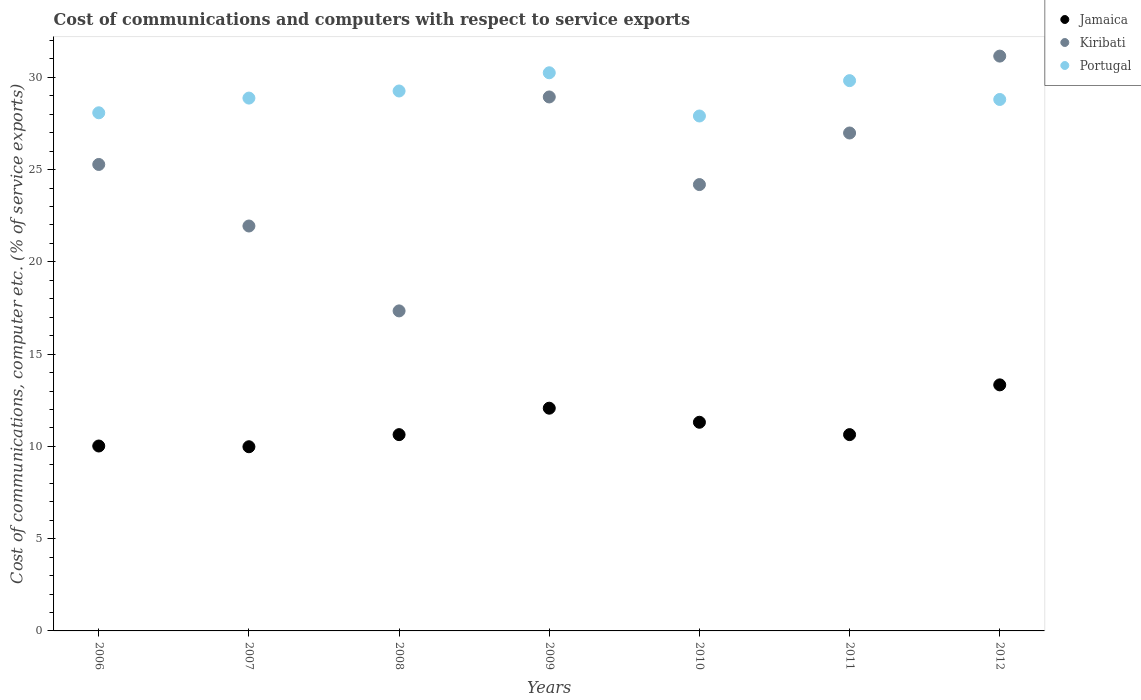Is the number of dotlines equal to the number of legend labels?
Your answer should be compact. Yes. What is the cost of communications and computers in Jamaica in 2006?
Your answer should be compact. 10.02. Across all years, what is the maximum cost of communications and computers in Portugal?
Give a very brief answer. 30.25. Across all years, what is the minimum cost of communications and computers in Jamaica?
Keep it short and to the point. 9.98. In which year was the cost of communications and computers in Portugal maximum?
Keep it short and to the point. 2009. In which year was the cost of communications and computers in Jamaica minimum?
Give a very brief answer. 2007. What is the total cost of communications and computers in Kiribati in the graph?
Your answer should be very brief. 175.83. What is the difference between the cost of communications and computers in Portugal in 2009 and that in 2010?
Offer a very short reply. 2.34. What is the difference between the cost of communications and computers in Kiribati in 2006 and the cost of communications and computers in Portugal in 2009?
Your answer should be very brief. -4.97. What is the average cost of communications and computers in Jamaica per year?
Provide a succinct answer. 11.14. In the year 2012, what is the difference between the cost of communications and computers in Portugal and cost of communications and computers in Kiribati?
Keep it short and to the point. -2.35. What is the ratio of the cost of communications and computers in Jamaica in 2006 to that in 2010?
Provide a short and direct response. 0.89. What is the difference between the highest and the second highest cost of communications and computers in Kiribati?
Provide a succinct answer. 2.21. What is the difference between the highest and the lowest cost of communications and computers in Jamaica?
Provide a short and direct response. 3.35. In how many years, is the cost of communications and computers in Portugal greater than the average cost of communications and computers in Portugal taken over all years?
Provide a short and direct response. 3. Is the sum of the cost of communications and computers in Kiribati in 2009 and 2011 greater than the maximum cost of communications and computers in Jamaica across all years?
Make the answer very short. Yes. Does the cost of communications and computers in Kiribati monotonically increase over the years?
Your answer should be very brief. No. How many years are there in the graph?
Give a very brief answer. 7. Are the values on the major ticks of Y-axis written in scientific E-notation?
Provide a short and direct response. No. Does the graph contain grids?
Give a very brief answer. No. How are the legend labels stacked?
Your answer should be compact. Vertical. What is the title of the graph?
Provide a succinct answer. Cost of communications and computers with respect to service exports. What is the label or title of the Y-axis?
Make the answer very short. Cost of communications, computer etc. (% of service exports). What is the Cost of communications, computer etc. (% of service exports) in Jamaica in 2006?
Keep it short and to the point. 10.02. What is the Cost of communications, computer etc. (% of service exports) in Kiribati in 2006?
Provide a short and direct response. 25.28. What is the Cost of communications, computer etc. (% of service exports) in Portugal in 2006?
Provide a short and direct response. 28.08. What is the Cost of communications, computer etc. (% of service exports) of Jamaica in 2007?
Provide a succinct answer. 9.98. What is the Cost of communications, computer etc. (% of service exports) in Kiribati in 2007?
Your answer should be very brief. 21.94. What is the Cost of communications, computer etc. (% of service exports) of Portugal in 2007?
Your response must be concise. 28.88. What is the Cost of communications, computer etc. (% of service exports) in Jamaica in 2008?
Keep it short and to the point. 10.64. What is the Cost of communications, computer etc. (% of service exports) of Kiribati in 2008?
Keep it short and to the point. 17.34. What is the Cost of communications, computer etc. (% of service exports) in Portugal in 2008?
Keep it short and to the point. 29.26. What is the Cost of communications, computer etc. (% of service exports) of Jamaica in 2009?
Provide a succinct answer. 12.07. What is the Cost of communications, computer etc. (% of service exports) of Kiribati in 2009?
Your answer should be compact. 28.94. What is the Cost of communications, computer etc. (% of service exports) of Portugal in 2009?
Give a very brief answer. 30.25. What is the Cost of communications, computer etc. (% of service exports) in Jamaica in 2010?
Make the answer very short. 11.31. What is the Cost of communications, computer etc. (% of service exports) in Kiribati in 2010?
Offer a very short reply. 24.19. What is the Cost of communications, computer etc. (% of service exports) of Portugal in 2010?
Provide a succinct answer. 27.91. What is the Cost of communications, computer etc. (% of service exports) of Jamaica in 2011?
Ensure brevity in your answer.  10.64. What is the Cost of communications, computer etc. (% of service exports) of Kiribati in 2011?
Your answer should be very brief. 26.98. What is the Cost of communications, computer etc. (% of service exports) in Portugal in 2011?
Give a very brief answer. 29.82. What is the Cost of communications, computer etc. (% of service exports) in Jamaica in 2012?
Your response must be concise. 13.33. What is the Cost of communications, computer etc. (% of service exports) in Kiribati in 2012?
Offer a terse response. 31.15. What is the Cost of communications, computer etc. (% of service exports) in Portugal in 2012?
Provide a short and direct response. 28.8. Across all years, what is the maximum Cost of communications, computer etc. (% of service exports) of Jamaica?
Your answer should be compact. 13.33. Across all years, what is the maximum Cost of communications, computer etc. (% of service exports) in Kiribati?
Offer a terse response. 31.15. Across all years, what is the maximum Cost of communications, computer etc. (% of service exports) of Portugal?
Ensure brevity in your answer.  30.25. Across all years, what is the minimum Cost of communications, computer etc. (% of service exports) in Jamaica?
Give a very brief answer. 9.98. Across all years, what is the minimum Cost of communications, computer etc. (% of service exports) of Kiribati?
Your answer should be compact. 17.34. Across all years, what is the minimum Cost of communications, computer etc. (% of service exports) in Portugal?
Ensure brevity in your answer.  27.91. What is the total Cost of communications, computer etc. (% of service exports) in Jamaica in the graph?
Make the answer very short. 77.99. What is the total Cost of communications, computer etc. (% of service exports) of Kiribati in the graph?
Give a very brief answer. 175.83. What is the total Cost of communications, computer etc. (% of service exports) in Portugal in the graph?
Offer a terse response. 202.99. What is the difference between the Cost of communications, computer etc. (% of service exports) of Jamaica in 2006 and that in 2007?
Keep it short and to the point. 0.04. What is the difference between the Cost of communications, computer etc. (% of service exports) of Kiribati in 2006 and that in 2007?
Your answer should be compact. 3.33. What is the difference between the Cost of communications, computer etc. (% of service exports) in Portugal in 2006 and that in 2007?
Ensure brevity in your answer.  -0.8. What is the difference between the Cost of communications, computer etc. (% of service exports) of Jamaica in 2006 and that in 2008?
Provide a short and direct response. -0.62. What is the difference between the Cost of communications, computer etc. (% of service exports) of Kiribati in 2006 and that in 2008?
Make the answer very short. 7.94. What is the difference between the Cost of communications, computer etc. (% of service exports) in Portugal in 2006 and that in 2008?
Your response must be concise. -1.18. What is the difference between the Cost of communications, computer etc. (% of service exports) of Jamaica in 2006 and that in 2009?
Your response must be concise. -2.05. What is the difference between the Cost of communications, computer etc. (% of service exports) of Kiribati in 2006 and that in 2009?
Make the answer very short. -3.66. What is the difference between the Cost of communications, computer etc. (% of service exports) of Portugal in 2006 and that in 2009?
Offer a terse response. -2.17. What is the difference between the Cost of communications, computer etc. (% of service exports) of Jamaica in 2006 and that in 2010?
Offer a terse response. -1.29. What is the difference between the Cost of communications, computer etc. (% of service exports) of Kiribati in 2006 and that in 2010?
Offer a very short reply. 1.09. What is the difference between the Cost of communications, computer etc. (% of service exports) in Portugal in 2006 and that in 2010?
Your response must be concise. 0.17. What is the difference between the Cost of communications, computer etc. (% of service exports) in Jamaica in 2006 and that in 2011?
Offer a very short reply. -0.62. What is the difference between the Cost of communications, computer etc. (% of service exports) of Kiribati in 2006 and that in 2011?
Offer a terse response. -1.71. What is the difference between the Cost of communications, computer etc. (% of service exports) of Portugal in 2006 and that in 2011?
Your answer should be very brief. -1.74. What is the difference between the Cost of communications, computer etc. (% of service exports) in Jamaica in 2006 and that in 2012?
Your answer should be very brief. -3.31. What is the difference between the Cost of communications, computer etc. (% of service exports) of Kiribati in 2006 and that in 2012?
Your answer should be compact. -5.87. What is the difference between the Cost of communications, computer etc. (% of service exports) of Portugal in 2006 and that in 2012?
Your answer should be compact. -0.72. What is the difference between the Cost of communications, computer etc. (% of service exports) of Jamaica in 2007 and that in 2008?
Provide a short and direct response. -0.66. What is the difference between the Cost of communications, computer etc. (% of service exports) of Kiribati in 2007 and that in 2008?
Ensure brevity in your answer.  4.6. What is the difference between the Cost of communications, computer etc. (% of service exports) of Portugal in 2007 and that in 2008?
Provide a succinct answer. -0.38. What is the difference between the Cost of communications, computer etc. (% of service exports) in Jamaica in 2007 and that in 2009?
Provide a succinct answer. -2.09. What is the difference between the Cost of communications, computer etc. (% of service exports) in Kiribati in 2007 and that in 2009?
Keep it short and to the point. -6.99. What is the difference between the Cost of communications, computer etc. (% of service exports) in Portugal in 2007 and that in 2009?
Offer a very short reply. -1.37. What is the difference between the Cost of communications, computer etc. (% of service exports) in Jamaica in 2007 and that in 2010?
Make the answer very short. -1.33. What is the difference between the Cost of communications, computer etc. (% of service exports) in Kiribati in 2007 and that in 2010?
Provide a short and direct response. -2.25. What is the difference between the Cost of communications, computer etc. (% of service exports) in Portugal in 2007 and that in 2010?
Make the answer very short. 0.97. What is the difference between the Cost of communications, computer etc. (% of service exports) of Jamaica in 2007 and that in 2011?
Give a very brief answer. -0.66. What is the difference between the Cost of communications, computer etc. (% of service exports) in Kiribati in 2007 and that in 2011?
Provide a short and direct response. -5.04. What is the difference between the Cost of communications, computer etc. (% of service exports) in Portugal in 2007 and that in 2011?
Your answer should be compact. -0.95. What is the difference between the Cost of communications, computer etc. (% of service exports) in Jamaica in 2007 and that in 2012?
Provide a short and direct response. -3.35. What is the difference between the Cost of communications, computer etc. (% of service exports) in Kiribati in 2007 and that in 2012?
Your answer should be very brief. -9.21. What is the difference between the Cost of communications, computer etc. (% of service exports) of Portugal in 2007 and that in 2012?
Make the answer very short. 0.07. What is the difference between the Cost of communications, computer etc. (% of service exports) in Jamaica in 2008 and that in 2009?
Keep it short and to the point. -1.43. What is the difference between the Cost of communications, computer etc. (% of service exports) in Kiribati in 2008 and that in 2009?
Your response must be concise. -11.59. What is the difference between the Cost of communications, computer etc. (% of service exports) in Portugal in 2008 and that in 2009?
Provide a short and direct response. -0.99. What is the difference between the Cost of communications, computer etc. (% of service exports) of Jamaica in 2008 and that in 2010?
Your response must be concise. -0.67. What is the difference between the Cost of communications, computer etc. (% of service exports) of Kiribati in 2008 and that in 2010?
Keep it short and to the point. -6.85. What is the difference between the Cost of communications, computer etc. (% of service exports) in Portugal in 2008 and that in 2010?
Provide a succinct answer. 1.35. What is the difference between the Cost of communications, computer etc. (% of service exports) of Jamaica in 2008 and that in 2011?
Your answer should be compact. -0. What is the difference between the Cost of communications, computer etc. (% of service exports) of Kiribati in 2008 and that in 2011?
Ensure brevity in your answer.  -9.64. What is the difference between the Cost of communications, computer etc. (% of service exports) in Portugal in 2008 and that in 2011?
Provide a short and direct response. -0.56. What is the difference between the Cost of communications, computer etc. (% of service exports) of Jamaica in 2008 and that in 2012?
Make the answer very short. -2.7. What is the difference between the Cost of communications, computer etc. (% of service exports) of Kiribati in 2008 and that in 2012?
Your response must be concise. -13.81. What is the difference between the Cost of communications, computer etc. (% of service exports) of Portugal in 2008 and that in 2012?
Your answer should be very brief. 0.46. What is the difference between the Cost of communications, computer etc. (% of service exports) in Jamaica in 2009 and that in 2010?
Keep it short and to the point. 0.76. What is the difference between the Cost of communications, computer etc. (% of service exports) of Kiribati in 2009 and that in 2010?
Provide a short and direct response. 4.75. What is the difference between the Cost of communications, computer etc. (% of service exports) in Portugal in 2009 and that in 2010?
Make the answer very short. 2.34. What is the difference between the Cost of communications, computer etc. (% of service exports) in Jamaica in 2009 and that in 2011?
Offer a terse response. 1.43. What is the difference between the Cost of communications, computer etc. (% of service exports) in Kiribati in 2009 and that in 2011?
Give a very brief answer. 1.95. What is the difference between the Cost of communications, computer etc. (% of service exports) in Portugal in 2009 and that in 2011?
Offer a very short reply. 0.43. What is the difference between the Cost of communications, computer etc. (% of service exports) of Jamaica in 2009 and that in 2012?
Keep it short and to the point. -1.26. What is the difference between the Cost of communications, computer etc. (% of service exports) of Kiribati in 2009 and that in 2012?
Keep it short and to the point. -2.21. What is the difference between the Cost of communications, computer etc. (% of service exports) in Portugal in 2009 and that in 2012?
Make the answer very short. 1.45. What is the difference between the Cost of communications, computer etc. (% of service exports) of Jamaica in 2010 and that in 2011?
Ensure brevity in your answer.  0.67. What is the difference between the Cost of communications, computer etc. (% of service exports) of Kiribati in 2010 and that in 2011?
Your answer should be very brief. -2.8. What is the difference between the Cost of communications, computer etc. (% of service exports) of Portugal in 2010 and that in 2011?
Give a very brief answer. -1.92. What is the difference between the Cost of communications, computer etc. (% of service exports) of Jamaica in 2010 and that in 2012?
Ensure brevity in your answer.  -2.03. What is the difference between the Cost of communications, computer etc. (% of service exports) of Kiribati in 2010 and that in 2012?
Your answer should be compact. -6.96. What is the difference between the Cost of communications, computer etc. (% of service exports) in Portugal in 2010 and that in 2012?
Give a very brief answer. -0.9. What is the difference between the Cost of communications, computer etc. (% of service exports) of Jamaica in 2011 and that in 2012?
Provide a short and direct response. -2.7. What is the difference between the Cost of communications, computer etc. (% of service exports) in Kiribati in 2011 and that in 2012?
Offer a very short reply. -4.17. What is the difference between the Cost of communications, computer etc. (% of service exports) in Portugal in 2011 and that in 2012?
Offer a terse response. 1.02. What is the difference between the Cost of communications, computer etc. (% of service exports) of Jamaica in 2006 and the Cost of communications, computer etc. (% of service exports) of Kiribati in 2007?
Keep it short and to the point. -11.92. What is the difference between the Cost of communications, computer etc. (% of service exports) in Jamaica in 2006 and the Cost of communications, computer etc. (% of service exports) in Portugal in 2007?
Make the answer very short. -18.85. What is the difference between the Cost of communications, computer etc. (% of service exports) in Kiribati in 2006 and the Cost of communications, computer etc. (% of service exports) in Portugal in 2007?
Ensure brevity in your answer.  -3.6. What is the difference between the Cost of communications, computer etc. (% of service exports) in Jamaica in 2006 and the Cost of communications, computer etc. (% of service exports) in Kiribati in 2008?
Your response must be concise. -7.32. What is the difference between the Cost of communications, computer etc. (% of service exports) in Jamaica in 2006 and the Cost of communications, computer etc. (% of service exports) in Portugal in 2008?
Ensure brevity in your answer.  -19.24. What is the difference between the Cost of communications, computer etc. (% of service exports) of Kiribati in 2006 and the Cost of communications, computer etc. (% of service exports) of Portugal in 2008?
Offer a very short reply. -3.98. What is the difference between the Cost of communications, computer etc. (% of service exports) in Jamaica in 2006 and the Cost of communications, computer etc. (% of service exports) in Kiribati in 2009?
Provide a short and direct response. -18.92. What is the difference between the Cost of communications, computer etc. (% of service exports) in Jamaica in 2006 and the Cost of communications, computer etc. (% of service exports) in Portugal in 2009?
Give a very brief answer. -20.23. What is the difference between the Cost of communications, computer etc. (% of service exports) of Kiribati in 2006 and the Cost of communications, computer etc. (% of service exports) of Portugal in 2009?
Offer a terse response. -4.97. What is the difference between the Cost of communications, computer etc. (% of service exports) in Jamaica in 2006 and the Cost of communications, computer etc. (% of service exports) in Kiribati in 2010?
Offer a very short reply. -14.17. What is the difference between the Cost of communications, computer etc. (% of service exports) of Jamaica in 2006 and the Cost of communications, computer etc. (% of service exports) of Portugal in 2010?
Provide a short and direct response. -17.88. What is the difference between the Cost of communications, computer etc. (% of service exports) in Kiribati in 2006 and the Cost of communications, computer etc. (% of service exports) in Portugal in 2010?
Your response must be concise. -2.63. What is the difference between the Cost of communications, computer etc. (% of service exports) of Jamaica in 2006 and the Cost of communications, computer etc. (% of service exports) of Kiribati in 2011?
Make the answer very short. -16.96. What is the difference between the Cost of communications, computer etc. (% of service exports) of Jamaica in 2006 and the Cost of communications, computer etc. (% of service exports) of Portugal in 2011?
Keep it short and to the point. -19.8. What is the difference between the Cost of communications, computer etc. (% of service exports) of Kiribati in 2006 and the Cost of communications, computer etc. (% of service exports) of Portugal in 2011?
Ensure brevity in your answer.  -4.54. What is the difference between the Cost of communications, computer etc. (% of service exports) in Jamaica in 2006 and the Cost of communications, computer etc. (% of service exports) in Kiribati in 2012?
Provide a succinct answer. -21.13. What is the difference between the Cost of communications, computer etc. (% of service exports) of Jamaica in 2006 and the Cost of communications, computer etc. (% of service exports) of Portugal in 2012?
Your response must be concise. -18.78. What is the difference between the Cost of communications, computer etc. (% of service exports) of Kiribati in 2006 and the Cost of communications, computer etc. (% of service exports) of Portugal in 2012?
Keep it short and to the point. -3.52. What is the difference between the Cost of communications, computer etc. (% of service exports) of Jamaica in 2007 and the Cost of communications, computer etc. (% of service exports) of Kiribati in 2008?
Offer a very short reply. -7.36. What is the difference between the Cost of communications, computer etc. (% of service exports) of Jamaica in 2007 and the Cost of communications, computer etc. (% of service exports) of Portugal in 2008?
Offer a very short reply. -19.28. What is the difference between the Cost of communications, computer etc. (% of service exports) of Kiribati in 2007 and the Cost of communications, computer etc. (% of service exports) of Portugal in 2008?
Offer a terse response. -7.32. What is the difference between the Cost of communications, computer etc. (% of service exports) of Jamaica in 2007 and the Cost of communications, computer etc. (% of service exports) of Kiribati in 2009?
Offer a terse response. -18.96. What is the difference between the Cost of communications, computer etc. (% of service exports) in Jamaica in 2007 and the Cost of communications, computer etc. (% of service exports) in Portugal in 2009?
Your response must be concise. -20.27. What is the difference between the Cost of communications, computer etc. (% of service exports) of Kiribati in 2007 and the Cost of communications, computer etc. (% of service exports) of Portugal in 2009?
Ensure brevity in your answer.  -8.3. What is the difference between the Cost of communications, computer etc. (% of service exports) of Jamaica in 2007 and the Cost of communications, computer etc. (% of service exports) of Kiribati in 2010?
Ensure brevity in your answer.  -14.21. What is the difference between the Cost of communications, computer etc. (% of service exports) of Jamaica in 2007 and the Cost of communications, computer etc. (% of service exports) of Portugal in 2010?
Your response must be concise. -17.92. What is the difference between the Cost of communications, computer etc. (% of service exports) in Kiribati in 2007 and the Cost of communications, computer etc. (% of service exports) in Portugal in 2010?
Make the answer very short. -5.96. What is the difference between the Cost of communications, computer etc. (% of service exports) in Jamaica in 2007 and the Cost of communications, computer etc. (% of service exports) in Kiribati in 2011?
Provide a short and direct response. -17. What is the difference between the Cost of communications, computer etc. (% of service exports) of Jamaica in 2007 and the Cost of communications, computer etc. (% of service exports) of Portugal in 2011?
Make the answer very short. -19.84. What is the difference between the Cost of communications, computer etc. (% of service exports) of Kiribati in 2007 and the Cost of communications, computer etc. (% of service exports) of Portugal in 2011?
Make the answer very short. -7.88. What is the difference between the Cost of communications, computer etc. (% of service exports) of Jamaica in 2007 and the Cost of communications, computer etc. (% of service exports) of Kiribati in 2012?
Provide a short and direct response. -21.17. What is the difference between the Cost of communications, computer etc. (% of service exports) of Jamaica in 2007 and the Cost of communications, computer etc. (% of service exports) of Portugal in 2012?
Your response must be concise. -18.82. What is the difference between the Cost of communications, computer etc. (% of service exports) in Kiribati in 2007 and the Cost of communications, computer etc. (% of service exports) in Portugal in 2012?
Give a very brief answer. -6.86. What is the difference between the Cost of communications, computer etc. (% of service exports) in Jamaica in 2008 and the Cost of communications, computer etc. (% of service exports) in Kiribati in 2009?
Your response must be concise. -18.3. What is the difference between the Cost of communications, computer etc. (% of service exports) of Jamaica in 2008 and the Cost of communications, computer etc. (% of service exports) of Portugal in 2009?
Make the answer very short. -19.61. What is the difference between the Cost of communications, computer etc. (% of service exports) in Kiribati in 2008 and the Cost of communications, computer etc. (% of service exports) in Portugal in 2009?
Keep it short and to the point. -12.9. What is the difference between the Cost of communications, computer etc. (% of service exports) of Jamaica in 2008 and the Cost of communications, computer etc. (% of service exports) of Kiribati in 2010?
Your response must be concise. -13.55. What is the difference between the Cost of communications, computer etc. (% of service exports) of Jamaica in 2008 and the Cost of communications, computer etc. (% of service exports) of Portugal in 2010?
Ensure brevity in your answer.  -17.27. What is the difference between the Cost of communications, computer etc. (% of service exports) in Kiribati in 2008 and the Cost of communications, computer etc. (% of service exports) in Portugal in 2010?
Provide a short and direct response. -10.56. What is the difference between the Cost of communications, computer etc. (% of service exports) of Jamaica in 2008 and the Cost of communications, computer etc. (% of service exports) of Kiribati in 2011?
Your answer should be compact. -16.35. What is the difference between the Cost of communications, computer etc. (% of service exports) of Jamaica in 2008 and the Cost of communications, computer etc. (% of service exports) of Portugal in 2011?
Provide a succinct answer. -19.18. What is the difference between the Cost of communications, computer etc. (% of service exports) in Kiribati in 2008 and the Cost of communications, computer etc. (% of service exports) in Portugal in 2011?
Give a very brief answer. -12.48. What is the difference between the Cost of communications, computer etc. (% of service exports) of Jamaica in 2008 and the Cost of communications, computer etc. (% of service exports) of Kiribati in 2012?
Your response must be concise. -20.51. What is the difference between the Cost of communications, computer etc. (% of service exports) in Jamaica in 2008 and the Cost of communications, computer etc. (% of service exports) in Portugal in 2012?
Give a very brief answer. -18.16. What is the difference between the Cost of communications, computer etc. (% of service exports) of Kiribati in 2008 and the Cost of communications, computer etc. (% of service exports) of Portugal in 2012?
Make the answer very short. -11.46. What is the difference between the Cost of communications, computer etc. (% of service exports) in Jamaica in 2009 and the Cost of communications, computer etc. (% of service exports) in Kiribati in 2010?
Keep it short and to the point. -12.12. What is the difference between the Cost of communications, computer etc. (% of service exports) in Jamaica in 2009 and the Cost of communications, computer etc. (% of service exports) in Portugal in 2010?
Make the answer very short. -15.84. What is the difference between the Cost of communications, computer etc. (% of service exports) of Kiribati in 2009 and the Cost of communications, computer etc. (% of service exports) of Portugal in 2010?
Provide a succinct answer. 1.03. What is the difference between the Cost of communications, computer etc. (% of service exports) of Jamaica in 2009 and the Cost of communications, computer etc. (% of service exports) of Kiribati in 2011?
Provide a short and direct response. -14.91. What is the difference between the Cost of communications, computer etc. (% of service exports) of Jamaica in 2009 and the Cost of communications, computer etc. (% of service exports) of Portugal in 2011?
Keep it short and to the point. -17.75. What is the difference between the Cost of communications, computer etc. (% of service exports) in Kiribati in 2009 and the Cost of communications, computer etc. (% of service exports) in Portugal in 2011?
Your answer should be compact. -0.88. What is the difference between the Cost of communications, computer etc. (% of service exports) of Jamaica in 2009 and the Cost of communications, computer etc. (% of service exports) of Kiribati in 2012?
Offer a very short reply. -19.08. What is the difference between the Cost of communications, computer etc. (% of service exports) of Jamaica in 2009 and the Cost of communications, computer etc. (% of service exports) of Portugal in 2012?
Provide a short and direct response. -16.73. What is the difference between the Cost of communications, computer etc. (% of service exports) in Kiribati in 2009 and the Cost of communications, computer etc. (% of service exports) in Portugal in 2012?
Give a very brief answer. 0.14. What is the difference between the Cost of communications, computer etc. (% of service exports) of Jamaica in 2010 and the Cost of communications, computer etc. (% of service exports) of Kiribati in 2011?
Your answer should be very brief. -15.68. What is the difference between the Cost of communications, computer etc. (% of service exports) in Jamaica in 2010 and the Cost of communications, computer etc. (% of service exports) in Portugal in 2011?
Offer a terse response. -18.51. What is the difference between the Cost of communications, computer etc. (% of service exports) in Kiribati in 2010 and the Cost of communications, computer etc. (% of service exports) in Portugal in 2011?
Your answer should be compact. -5.63. What is the difference between the Cost of communications, computer etc. (% of service exports) of Jamaica in 2010 and the Cost of communications, computer etc. (% of service exports) of Kiribati in 2012?
Give a very brief answer. -19.84. What is the difference between the Cost of communications, computer etc. (% of service exports) of Jamaica in 2010 and the Cost of communications, computer etc. (% of service exports) of Portugal in 2012?
Provide a short and direct response. -17.49. What is the difference between the Cost of communications, computer etc. (% of service exports) in Kiribati in 2010 and the Cost of communications, computer etc. (% of service exports) in Portugal in 2012?
Keep it short and to the point. -4.61. What is the difference between the Cost of communications, computer etc. (% of service exports) in Jamaica in 2011 and the Cost of communications, computer etc. (% of service exports) in Kiribati in 2012?
Ensure brevity in your answer.  -20.51. What is the difference between the Cost of communications, computer etc. (% of service exports) in Jamaica in 2011 and the Cost of communications, computer etc. (% of service exports) in Portugal in 2012?
Offer a terse response. -18.16. What is the difference between the Cost of communications, computer etc. (% of service exports) of Kiribati in 2011 and the Cost of communications, computer etc. (% of service exports) of Portugal in 2012?
Provide a succinct answer. -1.82. What is the average Cost of communications, computer etc. (% of service exports) in Jamaica per year?
Your answer should be compact. 11.14. What is the average Cost of communications, computer etc. (% of service exports) in Kiribati per year?
Keep it short and to the point. 25.12. What is the average Cost of communications, computer etc. (% of service exports) of Portugal per year?
Offer a very short reply. 29. In the year 2006, what is the difference between the Cost of communications, computer etc. (% of service exports) of Jamaica and Cost of communications, computer etc. (% of service exports) of Kiribati?
Provide a short and direct response. -15.26. In the year 2006, what is the difference between the Cost of communications, computer etc. (% of service exports) in Jamaica and Cost of communications, computer etc. (% of service exports) in Portugal?
Offer a terse response. -18.06. In the year 2006, what is the difference between the Cost of communications, computer etc. (% of service exports) in Kiribati and Cost of communications, computer etc. (% of service exports) in Portugal?
Your answer should be very brief. -2.8. In the year 2007, what is the difference between the Cost of communications, computer etc. (% of service exports) of Jamaica and Cost of communications, computer etc. (% of service exports) of Kiribati?
Your answer should be very brief. -11.96. In the year 2007, what is the difference between the Cost of communications, computer etc. (% of service exports) in Jamaica and Cost of communications, computer etc. (% of service exports) in Portugal?
Provide a short and direct response. -18.89. In the year 2007, what is the difference between the Cost of communications, computer etc. (% of service exports) of Kiribati and Cost of communications, computer etc. (% of service exports) of Portugal?
Your response must be concise. -6.93. In the year 2008, what is the difference between the Cost of communications, computer etc. (% of service exports) in Jamaica and Cost of communications, computer etc. (% of service exports) in Kiribati?
Provide a succinct answer. -6.71. In the year 2008, what is the difference between the Cost of communications, computer etc. (% of service exports) in Jamaica and Cost of communications, computer etc. (% of service exports) in Portugal?
Offer a terse response. -18.62. In the year 2008, what is the difference between the Cost of communications, computer etc. (% of service exports) of Kiribati and Cost of communications, computer etc. (% of service exports) of Portugal?
Offer a terse response. -11.92. In the year 2009, what is the difference between the Cost of communications, computer etc. (% of service exports) of Jamaica and Cost of communications, computer etc. (% of service exports) of Kiribati?
Keep it short and to the point. -16.87. In the year 2009, what is the difference between the Cost of communications, computer etc. (% of service exports) of Jamaica and Cost of communications, computer etc. (% of service exports) of Portugal?
Offer a very short reply. -18.18. In the year 2009, what is the difference between the Cost of communications, computer etc. (% of service exports) in Kiribati and Cost of communications, computer etc. (% of service exports) in Portugal?
Keep it short and to the point. -1.31. In the year 2010, what is the difference between the Cost of communications, computer etc. (% of service exports) of Jamaica and Cost of communications, computer etc. (% of service exports) of Kiribati?
Your answer should be compact. -12.88. In the year 2010, what is the difference between the Cost of communications, computer etc. (% of service exports) of Jamaica and Cost of communications, computer etc. (% of service exports) of Portugal?
Offer a very short reply. -16.6. In the year 2010, what is the difference between the Cost of communications, computer etc. (% of service exports) in Kiribati and Cost of communications, computer etc. (% of service exports) in Portugal?
Give a very brief answer. -3.72. In the year 2011, what is the difference between the Cost of communications, computer etc. (% of service exports) of Jamaica and Cost of communications, computer etc. (% of service exports) of Kiribati?
Your response must be concise. -16.35. In the year 2011, what is the difference between the Cost of communications, computer etc. (% of service exports) of Jamaica and Cost of communications, computer etc. (% of service exports) of Portugal?
Your answer should be very brief. -19.18. In the year 2011, what is the difference between the Cost of communications, computer etc. (% of service exports) in Kiribati and Cost of communications, computer etc. (% of service exports) in Portugal?
Ensure brevity in your answer.  -2.84. In the year 2012, what is the difference between the Cost of communications, computer etc. (% of service exports) of Jamaica and Cost of communications, computer etc. (% of service exports) of Kiribati?
Make the answer very short. -17.82. In the year 2012, what is the difference between the Cost of communications, computer etc. (% of service exports) in Jamaica and Cost of communications, computer etc. (% of service exports) in Portugal?
Your answer should be very brief. -15.47. In the year 2012, what is the difference between the Cost of communications, computer etc. (% of service exports) of Kiribati and Cost of communications, computer etc. (% of service exports) of Portugal?
Offer a very short reply. 2.35. What is the ratio of the Cost of communications, computer etc. (% of service exports) of Jamaica in 2006 to that in 2007?
Provide a short and direct response. 1. What is the ratio of the Cost of communications, computer etc. (% of service exports) in Kiribati in 2006 to that in 2007?
Offer a terse response. 1.15. What is the ratio of the Cost of communications, computer etc. (% of service exports) in Portugal in 2006 to that in 2007?
Your answer should be compact. 0.97. What is the ratio of the Cost of communications, computer etc. (% of service exports) in Jamaica in 2006 to that in 2008?
Your answer should be compact. 0.94. What is the ratio of the Cost of communications, computer etc. (% of service exports) in Kiribati in 2006 to that in 2008?
Ensure brevity in your answer.  1.46. What is the ratio of the Cost of communications, computer etc. (% of service exports) of Portugal in 2006 to that in 2008?
Keep it short and to the point. 0.96. What is the ratio of the Cost of communications, computer etc. (% of service exports) in Jamaica in 2006 to that in 2009?
Make the answer very short. 0.83. What is the ratio of the Cost of communications, computer etc. (% of service exports) of Kiribati in 2006 to that in 2009?
Offer a terse response. 0.87. What is the ratio of the Cost of communications, computer etc. (% of service exports) in Portugal in 2006 to that in 2009?
Your answer should be very brief. 0.93. What is the ratio of the Cost of communications, computer etc. (% of service exports) in Jamaica in 2006 to that in 2010?
Offer a very short reply. 0.89. What is the ratio of the Cost of communications, computer etc. (% of service exports) of Kiribati in 2006 to that in 2010?
Your answer should be compact. 1.05. What is the ratio of the Cost of communications, computer etc. (% of service exports) of Portugal in 2006 to that in 2010?
Make the answer very short. 1.01. What is the ratio of the Cost of communications, computer etc. (% of service exports) of Jamaica in 2006 to that in 2011?
Your answer should be compact. 0.94. What is the ratio of the Cost of communications, computer etc. (% of service exports) in Kiribati in 2006 to that in 2011?
Your answer should be very brief. 0.94. What is the ratio of the Cost of communications, computer etc. (% of service exports) in Portugal in 2006 to that in 2011?
Give a very brief answer. 0.94. What is the ratio of the Cost of communications, computer etc. (% of service exports) in Jamaica in 2006 to that in 2012?
Your answer should be very brief. 0.75. What is the ratio of the Cost of communications, computer etc. (% of service exports) in Kiribati in 2006 to that in 2012?
Ensure brevity in your answer.  0.81. What is the ratio of the Cost of communications, computer etc. (% of service exports) in Portugal in 2006 to that in 2012?
Your response must be concise. 0.97. What is the ratio of the Cost of communications, computer etc. (% of service exports) of Jamaica in 2007 to that in 2008?
Your response must be concise. 0.94. What is the ratio of the Cost of communications, computer etc. (% of service exports) in Kiribati in 2007 to that in 2008?
Your response must be concise. 1.27. What is the ratio of the Cost of communications, computer etc. (% of service exports) of Portugal in 2007 to that in 2008?
Keep it short and to the point. 0.99. What is the ratio of the Cost of communications, computer etc. (% of service exports) in Jamaica in 2007 to that in 2009?
Ensure brevity in your answer.  0.83. What is the ratio of the Cost of communications, computer etc. (% of service exports) of Kiribati in 2007 to that in 2009?
Give a very brief answer. 0.76. What is the ratio of the Cost of communications, computer etc. (% of service exports) of Portugal in 2007 to that in 2009?
Your response must be concise. 0.95. What is the ratio of the Cost of communications, computer etc. (% of service exports) in Jamaica in 2007 to that in 2010?
Offer a terse response. 0.88. What is the ratio of the Cost of communications, computer etc. (% of service exports) in Kiribati in 2007 to that in 2010?
Give a very brief answer. 0.91. What is the ratio of the Cost of communications, computer etc. (% of service exports) in Portugal in 2007 to that in 2010?
Your answer should be compact. 1.03. What is the ratio of the Cost of communications, computer etc. (% of service exports) in Jamaica in 2007 to that in 2011?
Keep it short and to the point. 0.94. What is the ratio of the Cost of communications, computer etc. (% of service exports) in Kiribati in 2007 to that in 2011?
Your response must be concise. 0.81. What is the ratio of the Cost of communications, computer etc. (% of service exports) in Portugal in 2007 to that in 2011?
Your answer should be very brief. 0.97. What is the ratio of the Cost of communications, computer etc. (% of service exports) in Jamaica in 2007 to that in 2012?
Provide a short and direct response. 0.75. What is the ratio of the Cost of communications, computer etc. (% of service exports) of Kiribati in 2007 to that in 2012?
Ensure brevity in your answer.  0.7. What is the ratio of the Cost of communications, computer etc. (% of service exports) of Jamaica in 2008 to that in 2009?
Your response must be concise. 0.88. What is the ratio of the Cost of communications, computer etc. (% of service exports) in Kiribati in 2008 to that in 2009?
Your answer should be compact. 0.6. What is the ratio of the Cost of communications, computer etc. (% of service exports) of Portugal in 2008 to that in 2009?
Make the answer very short. 0.97. What is the ratio of the Cost of communications, computer etc. (% of service exports) of Jamaica in 2008 to that in 2010?
Give a very brief answer. 0.94. What is the ratio of the Cost of communications, computer etc. (% of service exports) in Kiribati in 2008 to that in 2010?
Offer a very short reply. 0.72. What is the ratio of the Cost of communications, computer etc. (% of service exports) of Portugal in 2008 to that in 2010?
Make the answer very short. 1.05. What is the ratio of the Cost of communications, computer etc. (% of service exports) of Jamaica in 2008 to that in 2011?
Give a very brief answer. 1. What is the ratio of the Cost of communications, computer etc. (% of service exports) of Kiribati in 2008 to that in 2011?
Your answer should be very brief. 0.64. What is the ratio of the Cost of communications, computer etc. (% of service exports) in Portugal in 2008 to that in 2011?
Ensure brevity in your answer.  0.98. What is the ratio of the Cost of communications, computer etc. (% of service exports) of Jamaica in 2008 to that in 2012?
Offer a very short reply. 0.8. What is the ratio of the Cost of communications, computer etc. (% of service exports) in Kiribati in 2008 to that in 2012?
Offer a very short reply. 0.56. What is the ratio of the Cost of communications, computer etc. (% of service exports) of Portugal in 2008 to that in 2012?
Keep it short and to the point. 1.02. What is the ratio of the Cost of communications, computer etc. (% of service exports) in Jamaica in 2009 to that in 2010?
Give a very brief answer. 1.07. What is the ratio of the Cost of communications, computer etc. (% of service exports) in Kiribati in 2009 to that in 2010?
Your answer should be very brief. 1.2. What is the ratio of the Cost of communications, computer etc. (% of service exports) in Portugal in 2009 to that in 2010?
Ensure brevity in your answer.  1.08. What is the ratio of the Cost of communications, computer etc. (% of service exports) of Jamaica in 2009 to that in 2011?
Keep it short and to the point. 1.13. What is the ratio of the Cost of communications, computer etc. (% of service exports) of Kiribati in 2009 to that in 2011?
Provide a succinct answer. 1.07. What is the ratio of the Cost of communications, computer etc. (% of service exports) in Portugal in 2009 to that in 2011?
Ensure brevity in your answer.  1.01. What is the ratio of the Cost of communications, computer etc. (% of service exports) of Jamaica in 2009 to that in 2012?
Provide a short and direct response. 0.91. What is the ratio of the Cost of communications, computer etc. (% of service exports) in Kiribati in 2009 to that in 2012?
Give a very brief answer. 0.93. What is the ratio of the Cost of communications, computer etc. (% of service exports) of Portugal in 2009 to that in 2012?
Your answer should be compact. 1.05. What is the ratio of the Cost of communications, computer etc. (% of service exports) of Jamaica in 2010 to that in 2011?
Your response must be concise. 1.06. What is the ratio of the Cost of communications, computer etc. (% of service exports) of Kiribati in 2010 to that in 2011?
Offer a very short reply. 0.9. What is the ratio of the Cost of communications, computer etc. (% of service exports) of Portugal in 2010 to that in 2011?
Your response must be concise. 0.94. What is the ratio of the Cost of communications, computer etc. (% of service exports) of Jamaica in 2010 to that in 2012?
Make the answer very short. 0.85. What is the ratio of the Cost of communications, computer etc. (% of service exports) of Kiribati in 2010 to that in 2012?
Your answer should be compact. 0.78. What is the ratio of the Cost of communications, computer etc. (% of service exports) in Portugal in 2010 to that in 2012?
Give a very brief answer. 0.97. What is the ratio of the Cost of communications, computer etc. (% of service exports) in Jamaica in 2011 to that in 2012?
Provide a succinct answer. 0.8. What is the ratio of the Cost of communications, computer etc. (% of service exports) of Kiribati in 2011 to that in 2012?
Offer a very short reply. 0.87. What is the ratio of the Cost of communications, computer etc. (% of service exports) in Portugal in 2011 to that in 2012?
Provide a succinct answer. 1.04. What is the difference between the highest and the second highest Cost of communications, computer etc. (% of service exports) in Jamaica?
Offer a terse response. 1.26. What is the difference between the highest and the second highest Cost of communications, computer etc. (% of service exports) of Kiribati?
Your answer should be compact. 2.21. What is the difference between the highest and the second highest Cost of communications, computer etc. (% of service exports) of Portugal?
Your answer should be compact. 0.43. What is the difference between the highest and the lowest Cost of communications, computer etc. (% of service exports) in Jamaica?
Provide a short and direct response. 3.35. What is the difference between the highest and the lowest Cost of communications, computer etc. (% of service exports) of Kiribati?
Give a very brief answer. 13.81. What is the difference between the highest and the lowest Cost of communications, computer etc. (% of service exports) in Portugal?
Give a very brief answer. 2.34. 